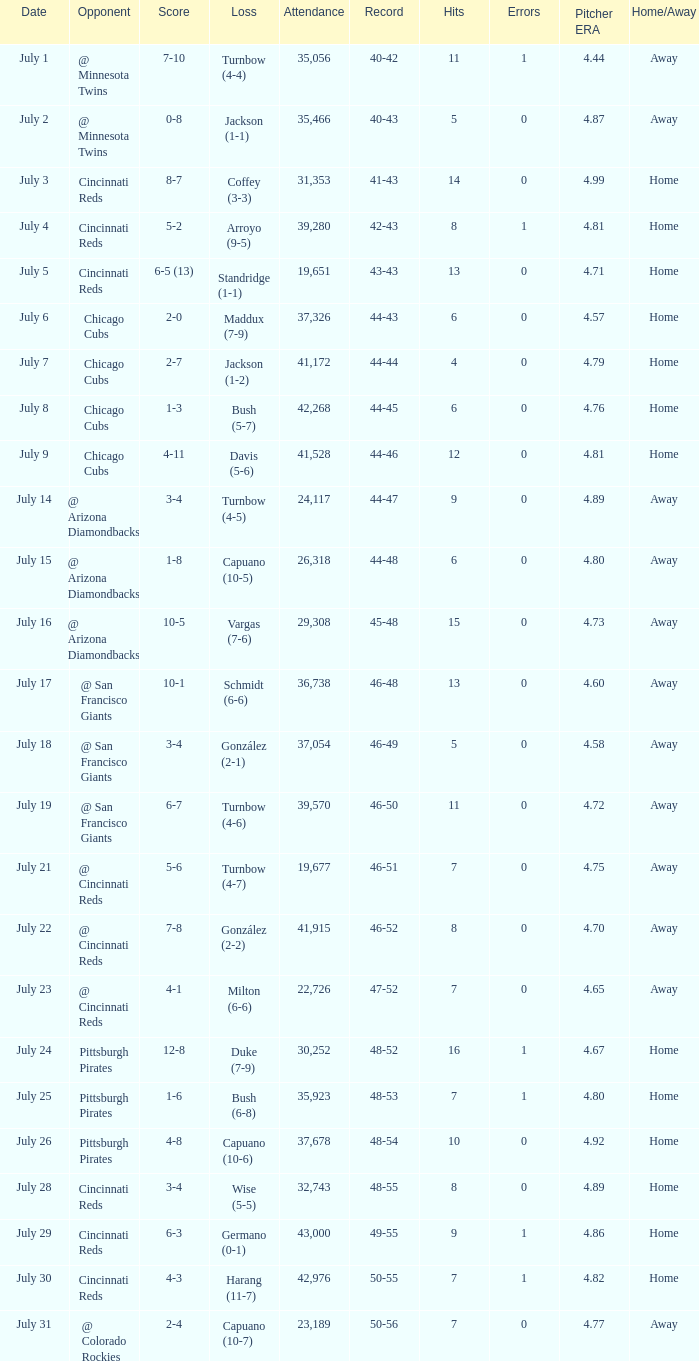What was the loss of the Brewers game when the record was 46-48? Schmidt (6-6). 